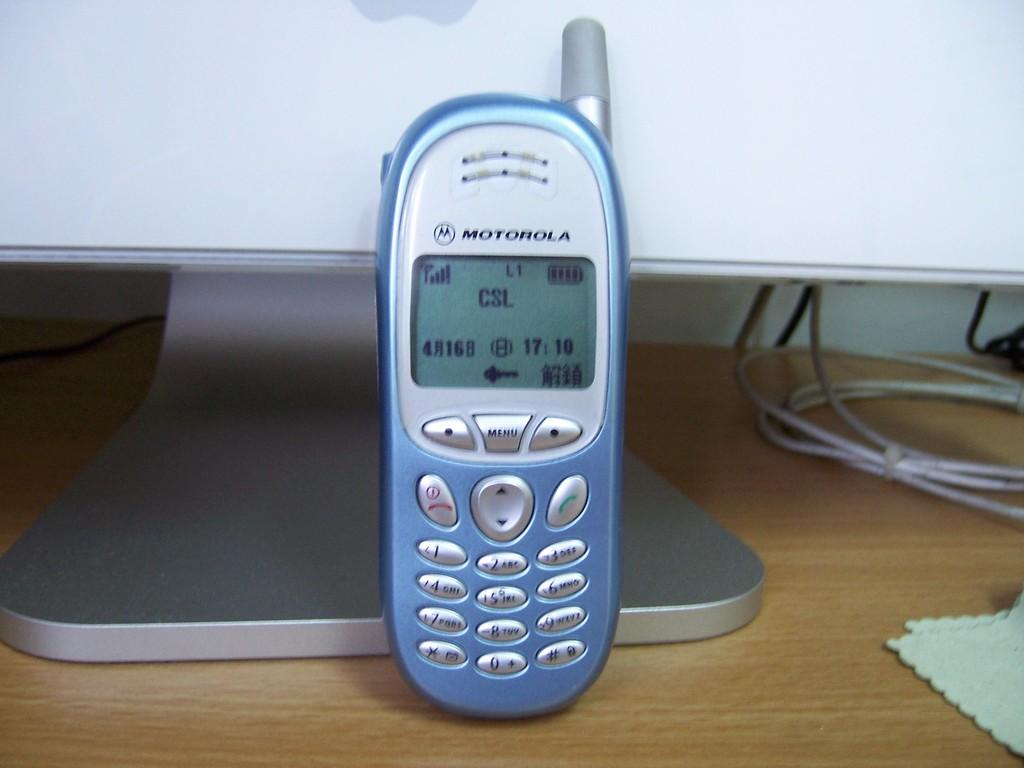What type of phone brand is on the table?
Ensure brevity in your answer.  Motorola. What time is it, according to the phone?
Your answer should be compact. 17:10. 